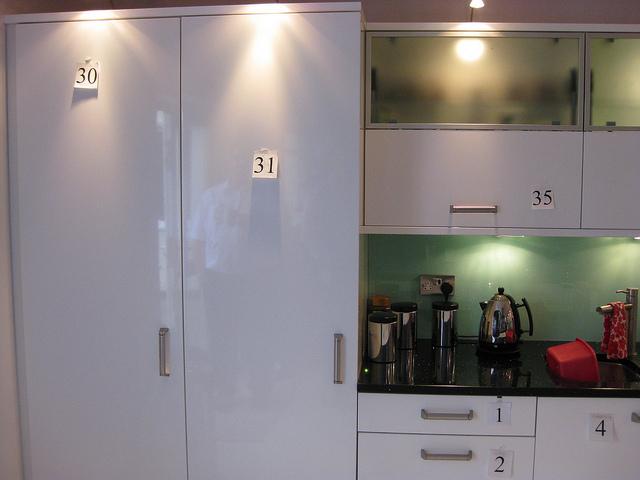What numbers are shown?
Short answer required. 30, 31, 35, 1, 2, 4. What color are the lights above the counter?
Keep it brief. White. Where is the chrome carafe?
Give a very brief answer. On counter. 